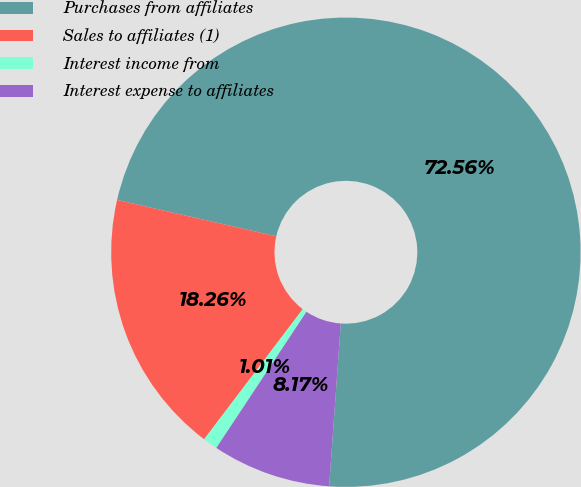Convert chart to OTSL. <chart><loc_0><loc_0><loc_500><loc_500><pie_chart><fcel>Purchases from affiliates<fcel>Sales to affiliates (1)<fcel>Interest income from<fcel>Interest expense to affiliates<nl><fcel>72.55%<fcel>18.26%<fcel>1.01%<fcel>8.17%<nl></chart> 